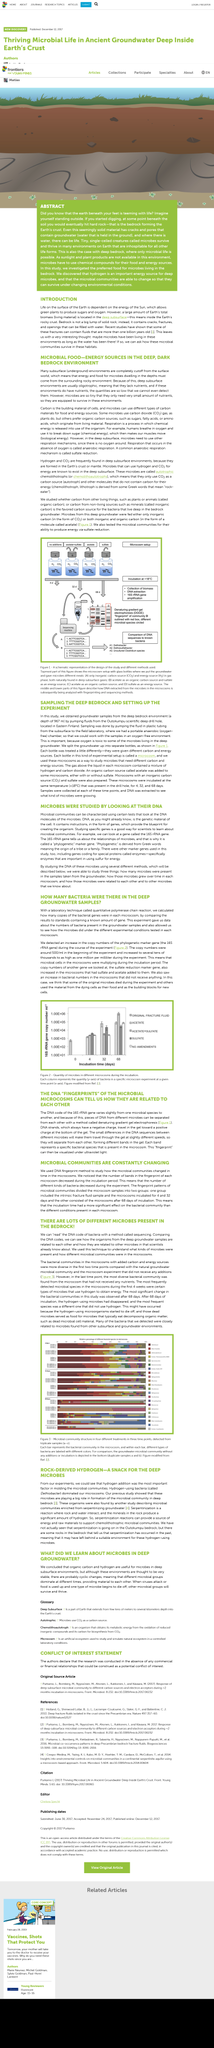Mention a couple of crucial points in this snapshot. It is estimated that some of the fluids in the bedrock are over one billion years old. Subsurface refers to underground areas, including those beneath the earth's surface and those that extend into the ground. The energy from the Sun allows for green plants to produce sugars and oxygen through a process known as photosynthesis. The experiment allows for the observation and identification of microbes and bacteria present in groundwater samples. Microbes can survive in deep groundwater, but there are likely cyclic changes in the environment that lead to different microbial groups dominating at different times. 